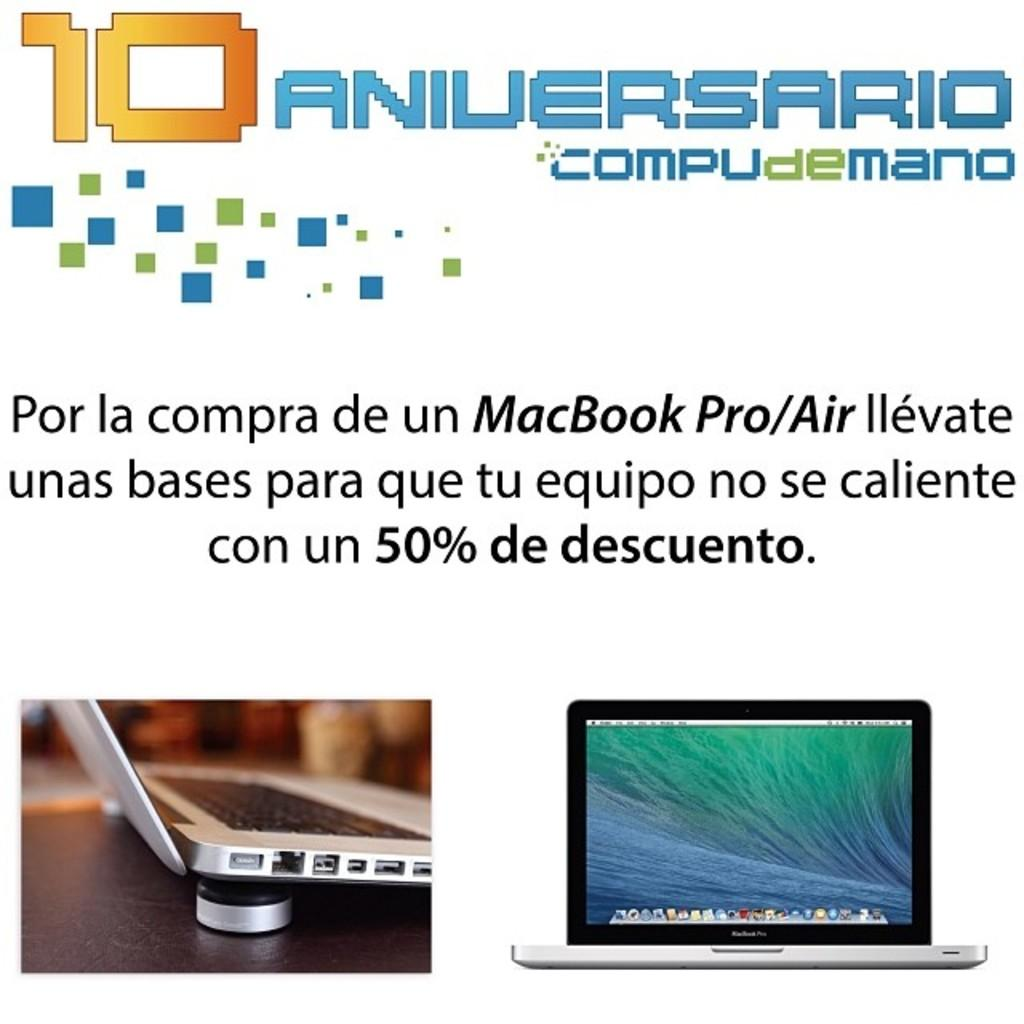Provide a one-sentence caption for the provided image. COMPUdeMANO is celebrating their 10 Year anniversary by offering a 50% discount on the MacBook Pro/Air. 